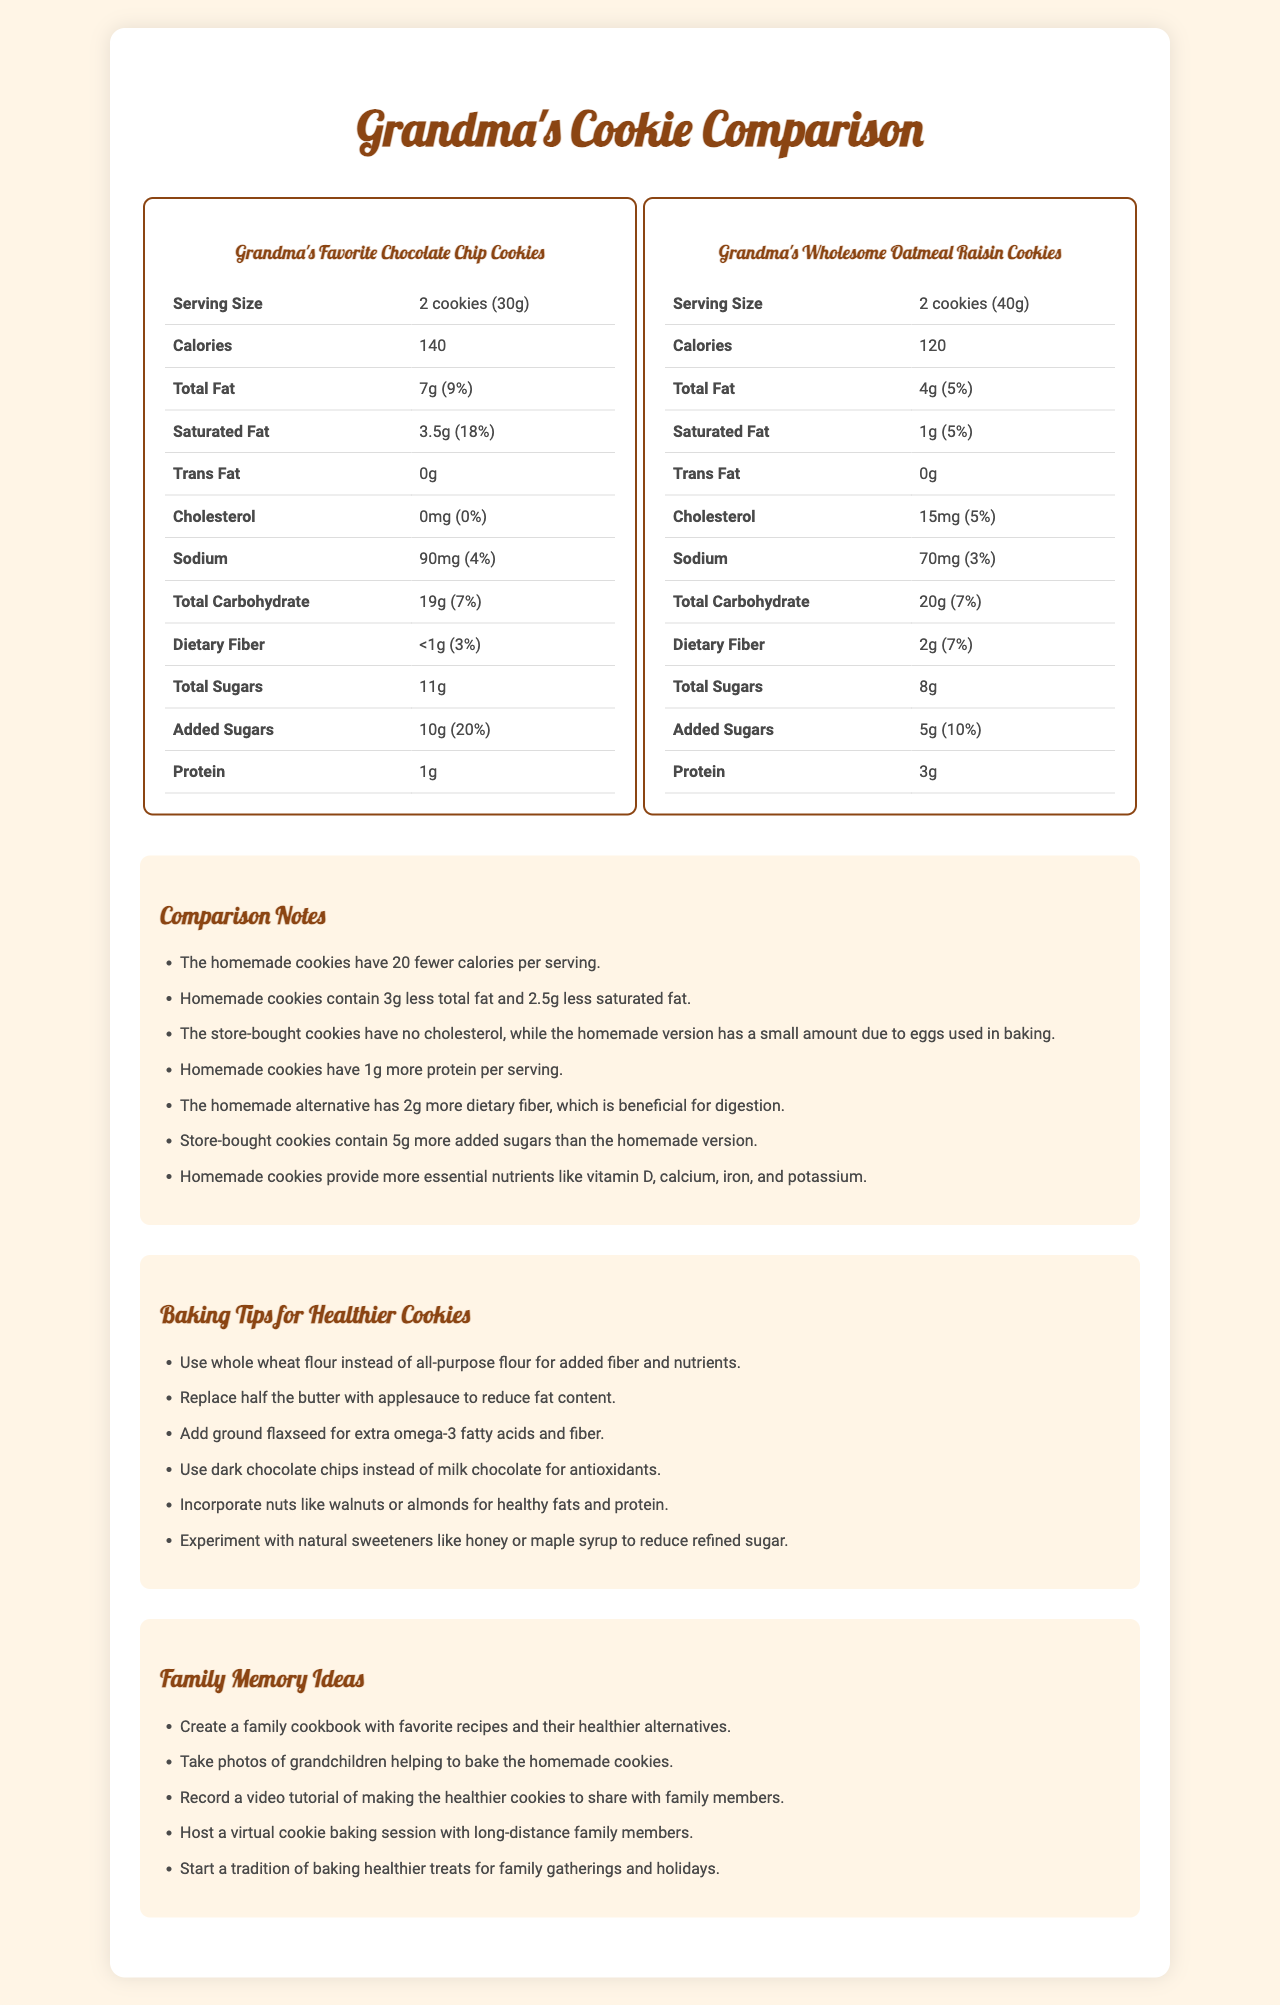what is the serving size of Grandma's Favorite Chocolate Chip Cookies? The serving size is specified in the nutrition label for Grandma's Favorite Chocolate Chip Cookies, listed as "2 cookies (30g)".
Answer: 2 cookies (30g) how many servings per container does the homemade oatmeal raisin cookies have? The number of servings per container for the homemade oatmeal raisin cookies is listed as 10 in the nutrition label.
Answer: 10 how much dietary fiber do the homemade cookies contain? The dietary fiber content for the homemade oatmeal raisin cookies is listed as "2g" on the nutrition label.
Answer: 2g which cookie has more total carbohydrates per serving? A. Store-bought Chocolate Chip Cookies B. Homemade Oatmeal Raisin Cookies The homemade oatmeal raisin cookies have 20g of total carbohydrates per serving whereas the store-bought chocolate chip cookies have 19g.
Answer: B which cookie has less total fat per serving? I. Store-bought Chocolate Chip Cookies II. Homemade Oatmeal Raisin Cookies The store-bought chocolate chip cookies have 7g of total fat per serving, while the homemade oatmeal raisin cookies have 4g per serving.
Answer: II does the store-bought snack contain any cholesterol? The nutrition label for the store-bought chocolate chip cookies lists "0mg" of cholesterol, confirming that it contains no cholesterol.
Answer: No what is the difference in added sugars between the store-bought and homemade cookies? According to the comparison notes, the store-bought cookies have 10g of added sugars whereas the homemade cookies have 5g, making the difference 5g.
Answer: 5g which cookie provides more protein per serving? The homemade oatmeal raisin cookies contain 3g of protein per serving, whereas the store-bought chocolate chip cookies contain only 1g per serving.
Answer: Homemade Oatmeal Raisin Cookies what tips can be used to reduce the fat content in homemade cookies? One of the baking tips provided is to replace half the butter with applesauce to reduce the fat content in the homemade cookies.
Answer: Replace half the butter with applesauce how does the serving size of the homemade cookie compare to the store-bought cookie? The serving size of the homemade oatmeal raisin cookie is 40g, whereas the store-bought chocolate chip cookie's serving size is 30g, making the homemade cookie 10g larger per serving.
Answer: 10g larger what essential nutrients are more abundant in the homemade cookies? A. Vitamin D B. Calcium C. Iron D. Potassium E. All of the above According to the comparison notes, the homemade cookies provide more essential nutrients like vitamin D, calcium, iron, and potassium.
Answer: E what can you replace all-purpose flour with in homemade cookies to add fiber? One of the baking tips suggests using whole wheat flour instead of all-purpose flour to add fiber and nutrients.
Answer: Whole wheat flour how many calories are in a serving of Grandma's Wholesome Oatmeal Raisin Cookies? The nutrition label for the homemade oatmeal raisin cookies lists 120 calories per serving.
Answer: 120 does the document provide information on homemade cookie recipes? The document contains nutrition labels, baking tips, and memory ideas, but does not provide explicit recipes for the homemade cookies.
Answer: No summarize the main idea of the document The document juxtaposes the nutritional information of store-bought and homemade cookies, emphasizing the healthier aspects of homemade options. Additionally, it offers practical tips for making cookies healthier and suggests various activities to create family memories centered around baking.
Answer: The document provides a comparison between store-bought chocolate chip cookies and homemade oatmeal raisin cookies, highlighting nutritional differences. It includes tips for healthy baking and ideas for creating family memories through baking activities. 